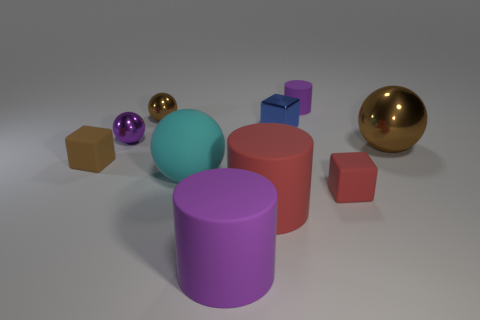Is there anything else that has the same size as the purple metallic thing?
Provide a short and direct response. Yes. There is a brown ball on the left side of the brown shiny sphere to the right of the red matte cube; what is it made of?
Give a very brief answer. Metal. What number of matte objects are either brown balls or tiny brown cubes?
Your answer should be very brief. 1. There is another small metallic object that is the same shape as the small brown shiny thing; what is its color?
Your response must be concise. Purple. How many other tiny cubes are the same color as the small shiny cube?
Offer a very short reply. 0. There is a rubber block on the right side of the big red thing; are there any objects to the right of it?
Your response must be concise. Yes. How many objects are on the left side of the big shiny ball and behind the red matte block?
Give a very brief answer. 6. What number of small balls are made of the same material as the red cylinder?
Your answer should be compact. 0. There is a brown shiny ball on the right side of the cylinder to the right of the large red matte cylinder; what size is it?
Provide a succinct answer. Large. Is there another matte object of the same shape as the big purple thing?
Your answer should be compact. Yes. 